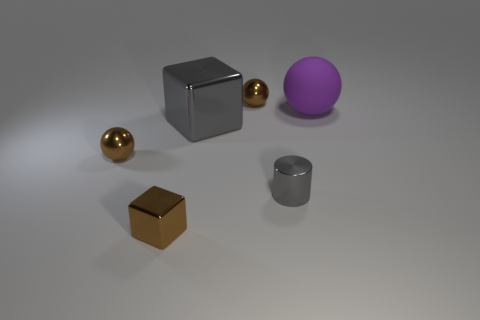Subtract all purple spheres. Subtract all red cylinders. How many spheres are left? 2 Add 2 large cyan shiny cubes. How many objects exist? 8 Subtract all blocks. How many objects are left? 4 Add 4 big purple matte objects. How many big purple matte objects exist? 5 Subtract 0 purple blocks. How many objects are left? 6 Subtract all large cyan rubber cylinders. Subtract all big balls. How many objects are left? 5 Add 3 gray things. How many gray things are left? 5 